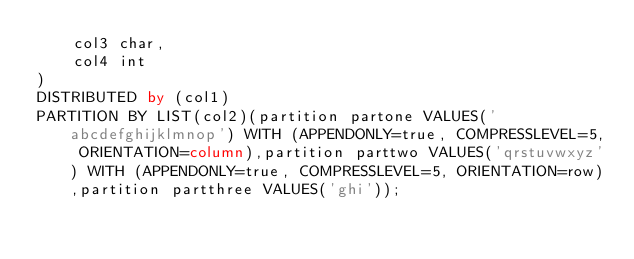<code> <loc_0><loc_0><loc_500><loc_500><_SQL_>    col3 char,
    col4 int
) 
DISTRIBUTED by (col1)
PARTITION BY LIST(col2)(partition partone VALUES('abcdefghijklmnop') WITH (APPENDONLY=true, COMPRESSLEVEL=5, ORIENTATION=column),partition parttwo VALUES('qrstuvwxyz') WITH (APPENDONLY=true, COMPRESSLEVEL=5, ORIENTATION=row),partition partthree VALUES('ghi'));
</code> 